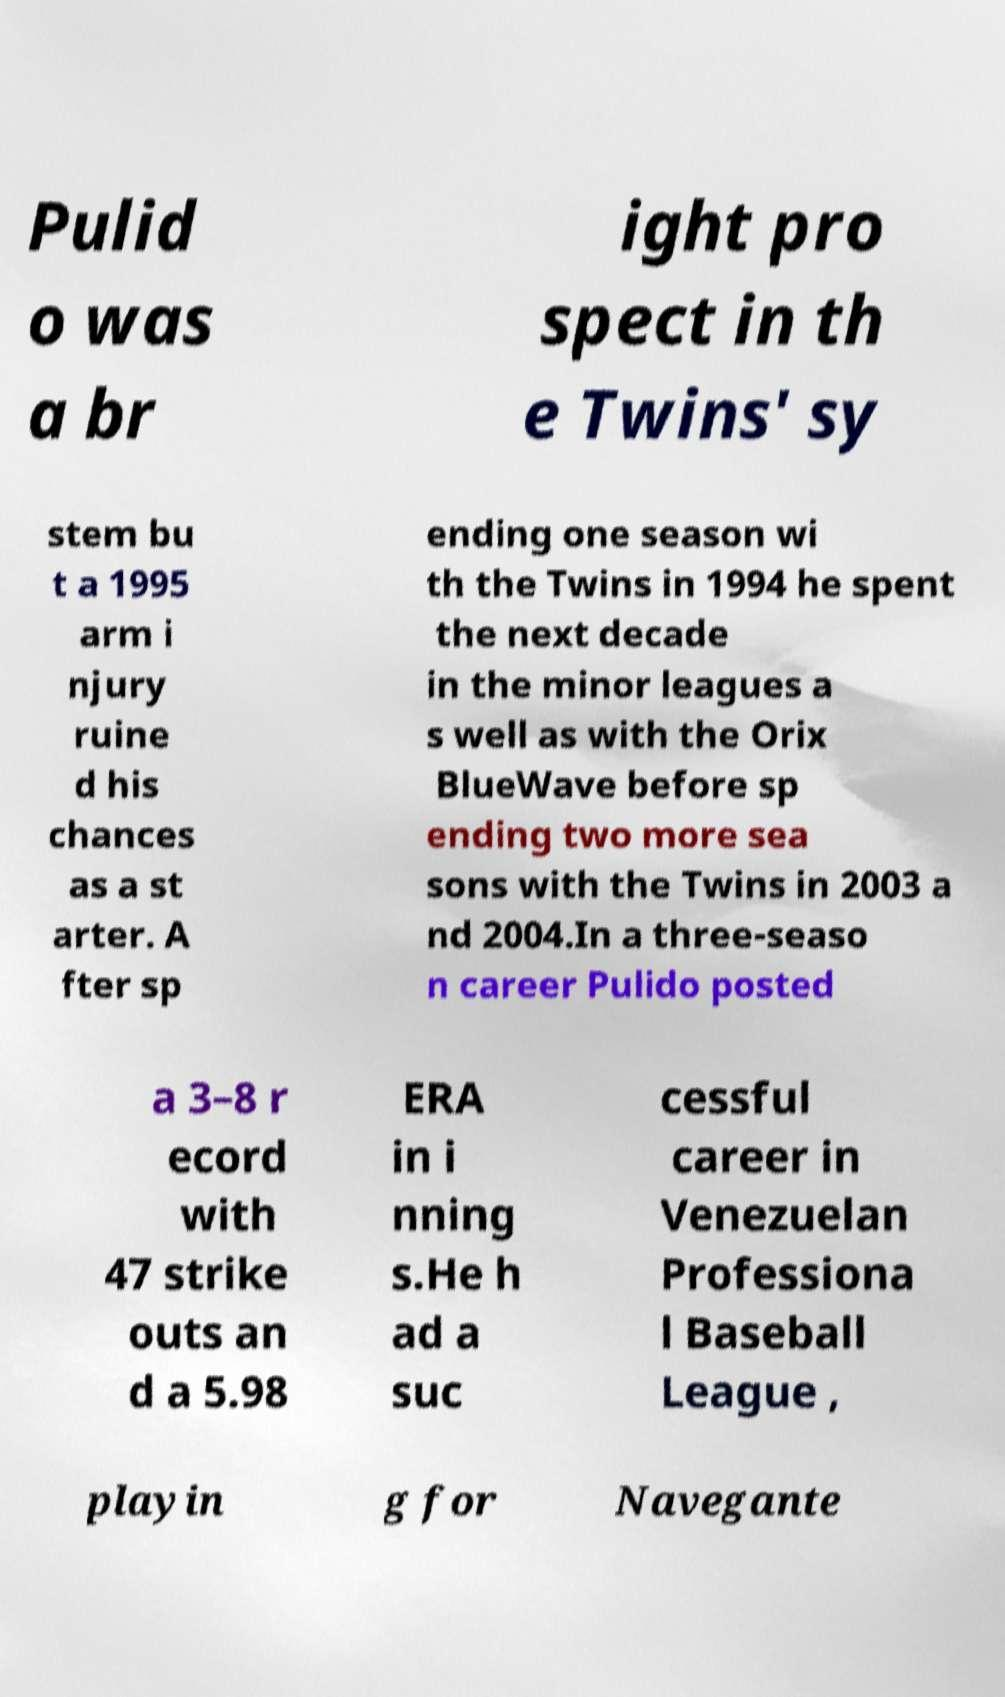Can you accurately transcribe the text from the provided image for me? Pulid o was a br ight pro spect in th e Twins' sy stem bu t a 1995 arm i njury ruine d his chances as a st arter. A fter sp ending one season wi th the Twins in 1994 he spent the next decade in the minor leagues a s well as with the Orix BlueWave before sp ending two more sea sons with the Twins in 2003 a nd 2004.In a three-seaso n career Pulido posted a 3–8 r ecord with 47 strike outs an d a 5.98 ERA in i nning s.He h ad a suc cessful career in Venezuelan Professiona l Baseball League , playin g for Navegante 